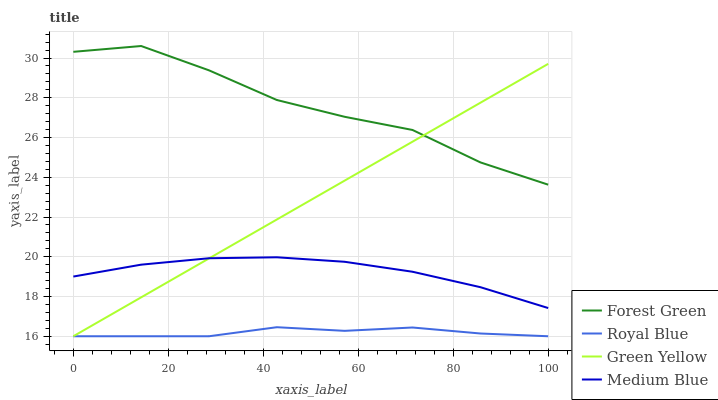Does Royal Blue have the minimum area under the curve?
Answer yes or no. Yes. Does Forest Green have the maximum area under the curve?
Answer yes or no. Yes. Does Green Yellow have the minimum area under the curve?
Answer yes or no. No. Does Green Yellow have the maximum area under the curve?
Answer yes or no. No. Is Green Yellow the smoothest?
Answer yes or no. Yes. Is Forest Green the roughest?
Answer yes or no. Yes. Is Forest Green the smoothest?
Answer yes or no. No. Is Green Yellow the roughest?
Answer yes or no. No. Does Forest Green have the lowest value?
Answer yes or no. No. Does Green Yellow have the highest value?
Answer yes or no. No. Is Royal Blue less than Forest Green?
Answer yes or no. Yes. Is Forest Green greater than Royal Blue?
Answer yes or no. Yes. Does Royal Blue intersect Forest Green?
Answer yes or no. No. 